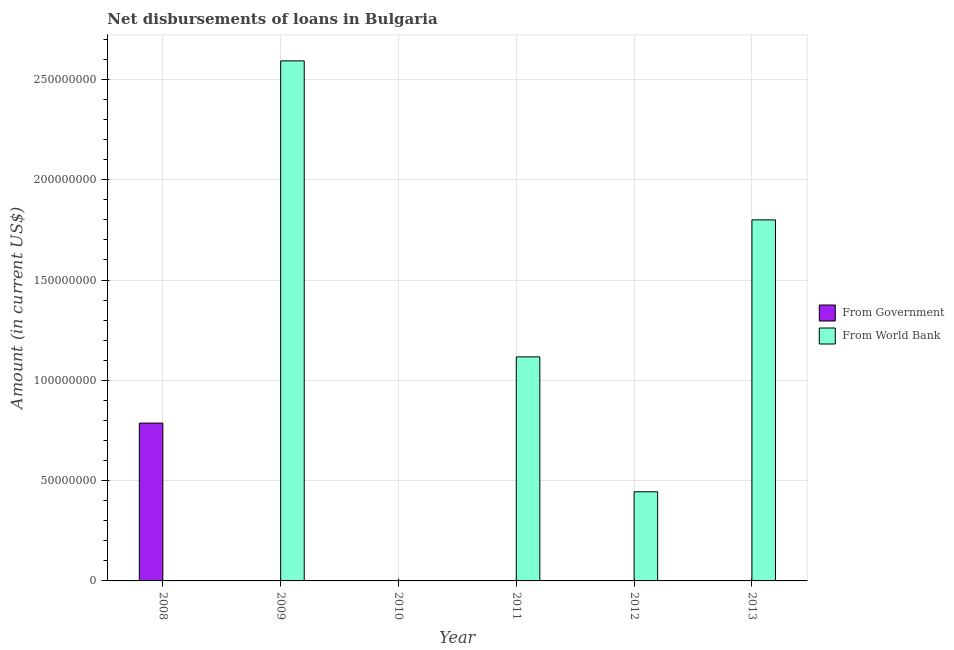How many different coloured bars are there?
Your answer should be very brief. 2. Are the number of bars on each tick of the X-axis equal?
Your response must be concise. No. How many bars are there on the 3rd tick from the right?
Provide a succinct answer. 1. What is the label of the 2nd group of bars from the left?
Your response must be concise. 2009. In how many cases, is the number of bars for a given year not equal to the number of legend labels?
Provide a succinct answer. 6. What is the net disbursements of loan from government in 2013?
Keep it short and to the point. 0. Across all years, what is the maximum net disbursements of loan from world bank?
Offer a very short reply. 2.59e+08. What is the total net disbursements of loan from world bank in the graph?
Ensure brevity in your answer.  5.95e+08. What is the difference between the net disbursements of loan from world bank in 2009 and that in 2012?
Your answer should be very brief. 2.15e+08. What is the difference between the net disbursements of loan from world bank in 2008 and the net disbursements of loan from government in 2010?
Your response must be concise. 0. What is the average net disbursements of loan from government per year?
Make the answer very short. 1.31e+07. In how many years, is the net disbursements of loan from government greater than 110000000 US$?
Give a very brief answer. 0. What is the difference between the highest and the second highest net disbursements of loan from world bank?
Your response must be concise. 7.93e+07. What is the difference between the highest and the lowest net disbursements of loan from government?
Make the answer very short. 7.87e+07. Are the values on the major ticks of Y-axis written in scientific E-notation?
Offer a terse response. No. Where does the legend appear in the graph?
Keep it short and to the point. Center right. How many legend labels are there?
Ensure brevity in your answer.  2. How are the legend labels stacked?
Provide a succinct answer. Vertical. What is the title of the graph?
Make the answer very short. Net disbursements of loans in Bulgaria. Does "RDB nonconcessional" appear as one of the legend labels in the graph?
Offer a terse response. No. What is the label or title of the Y-axis?
Your response must be concise. Amount (in current US$). What is the Amount (in current US$) of From Government in 2008?
Make the answer very short. 7.87e+07. What is the Amount (in current US$) in From World Bank in 2008?
Ensure brevity in your answer.  0. What is the Amount (in current US$) in From Government in 2009?
Give a very brief answer. 0. What is the Amount (in current US$) of From World Bank in 2009?
Provide a succinct answer. 2.59e+08. What is the Amount (in current US$) of From Government in 2010?
Ensure brevity in your answer.  0. What is the Amount (in current US$) in From Government in 2011?
Give a very brief answer. 0. What is the Amount (in current US$) in From World Bank in 2011?
Offer a terse response. 1.12e+08. What is the Amount (in current US$) in From Government in 2012?
Your answer should be compact. 0. What is the Amount (in current US$) of From World Bank in 2012?
Your response must be concise. 4.44e+07. What is the Amount (in current US$) of From Government in 2013?
Give a very brief answer. 0. What is the Amount (in current US$) in From World Bank in 2013?
Provide a succinct answer. 1.80e+08. Across all years, what is the maximum Amount (in current US$) in From Government?
Your answer should be very brief. 7.87e+07. Across all years, what is the maximum Amount (in current US$) of From World Bank?
Your answer should be compact. 2.59e+08. What is the total Amount (in current US$) in From Government in the graph?
Ensure brevity in your answer.  7.87e+07. What is the total Amount (in current US$) of From World Bank in the graph?
Ensure brevity in your answer.  5.95e+08. What is the difference between the Amount (in current US$) of From World Bank in 2009 and that in 2011?
Provide a short and direct response. 1.48e+08. What is the difference between the Amount (in current US$) of From World Bank in 2009 and that in 2012?
Your response must be concise. 2.15e+08. What is the difference between the Amount (in current US$) in From World Bank in 2009 and that in 2013?
Ensure brevity in your answer.  7.93e+07. What is the difference between the Amount (in current US$) in From World Bank in 2011 and that in 2012?
Your answer should be very brief. 6.72e+07. What is the difference between the Amount (in current US$) of From World Bank in 2011 and that in 2013?
Provide a succinct answer. -6.83e+07. What is the difference between the Amount (in current US$) of From World Bank in 2012 and that in 2013?
Provide a succinct answer. -1.36e+08. What is the difference between the Amount (in current US$) in From Government in 2008 and the Amount (in current US$) in From World Bank in 2009?
Keep it short and to the point. -1.81e+08. What is the difference between the Amount (in current US$) in From Government in 2008 and the Amount (in current US$) in From World Bank in 2011?
Offer a very short reply. -3.30e+07. What is the difference between the Amount (in current US$) of From Government in 2008 and the Amount (in current US$) of From World Bank in 2012?
Make the answer very short. 3.42e+07. What is the difference between the Amount (in current US$) in From Government in 2008 and the Amount (in current US$) in From World Bank in 2013?
Provide a short and direct response. -1.01e+08. What is the average Amount (in current US$) in From Government per year?
Make the answer very short. 1.31e+07. What is the average Amount (in current US$) of From World Bank per year?
Keep it short and to the point. 9.92e+07. What is the ratio of the Amount (in current US$) in From World Bank in 2009 to that in 2011?
Your answer should be very brief. 2.32. What is the ratio of the Amount (in current US$) in From World Bank in 2009 to that in 2012?
Your answer should be compact. 5.83. What is the ratio of the Amount (in current US$) in From World Bank in 2009 to that in 2013?
Your answer should be very brief. 1.44. What is the ratio of the Amount (in current US$) in From World Bank in 2011 to that in 2012?
Give a very brief answer. 2.51. What is the ratio of the Amount (in current US$) of From World Bank in 2011 to that in 2013?
Make the answer very short. 0.62. What is the ratio of the Amount (in current US$) of From World Bank in 2012 to that in 2013?
Keep it short and to the point. 0.25. What is the difference between the highest and the second highest Amount (in current US$) in From World Bank?
Make the answer very short. 7.93e+07. What is the difference between the highest and the lowest Amount (in current US$) of From Government?
Provide a short and direct response. 7.87e+07. What is the difference between the highest and the lowest Amount (in current US$) in From World Bank?
Your response must be concise. 2.59e+08. 